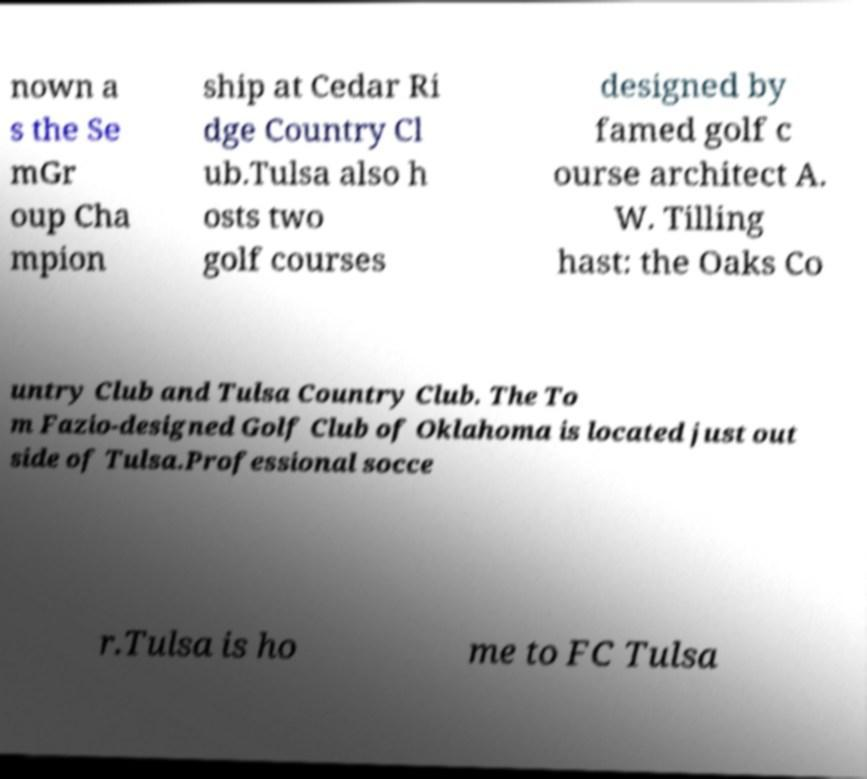Could you assist in decoding the text presented in this image and type it out clearly? nown a s the Se mGr oup Cha mpion ship at Cedar Ri dge Country Cl ub.Tulsa also h osts two golf courses designed by famed golf c ourse architect A. W. Tilling hast: the Oaks Co untry Club and Tulsa Country Club. The To m Fazio-designed Golf Club of Oklahoma is located just out side of Tulsa.Professional socce r.Tulsa is ho me to FC Tulsa 